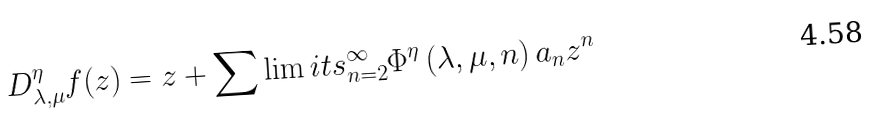<formula> <loc_0><loc_0><loc_500><loc_500>D _ { \lambda , \mu } ^ { \eta } f ( z ) = z + \sum \lim i t s _ { n = 2 } ^ { \infty } \Phi ^ { \eta } \left ( \lambda , \mu , n \right ) a _ { n } z ^ { n }</formula> 